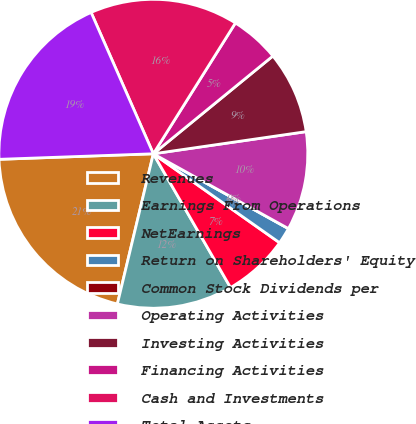Convert chart. <chart><loc_0><loc_0><loc_500><loc_500><pie_chart><fcel>Revenues<fcel>Earnings From Operations<fcel>NetEarnings<fcel>Return on Shareholders' Equity<fcel>Common Stock Dividends per<fcel>Operating Activities<fcel>Investing Activities<fcel>Financing Activities<fcel>Cash and Investments<fcel>Total Assets<nl><fcel>20.69%<fcel>12.07%<fcel>6.9%<fcel>1.72%<fcel>0.0%<fcel>10.34%<fcel>8.62%<fcel>5.17%<fcel>15.52%<fcel>18.97%<nl></chart> 